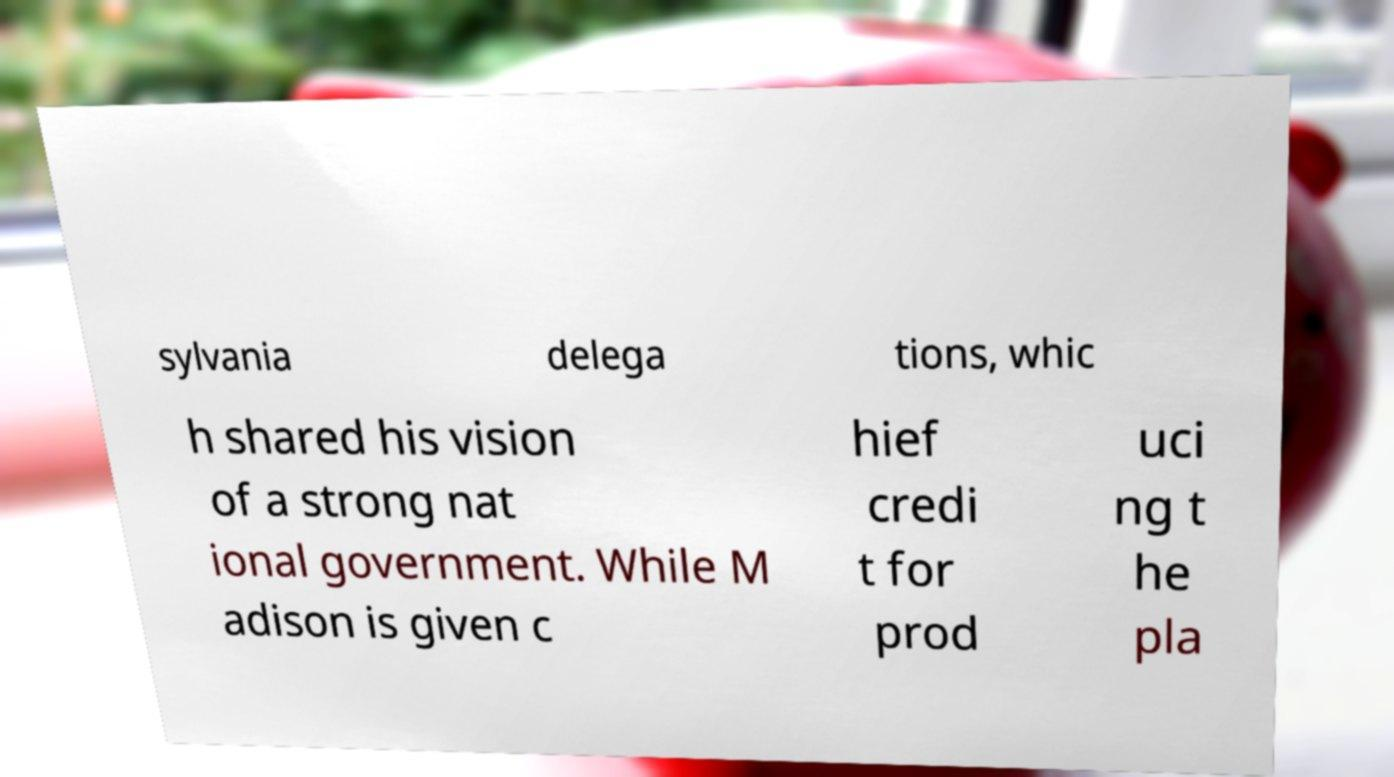For documentation purposes, I need the text within this image transcribed. Could you provide that? sylvania delega tions, whic h shared his vision of a strong nat ional government. While M adison is given c hief credi t for prod uci ng t he pla 